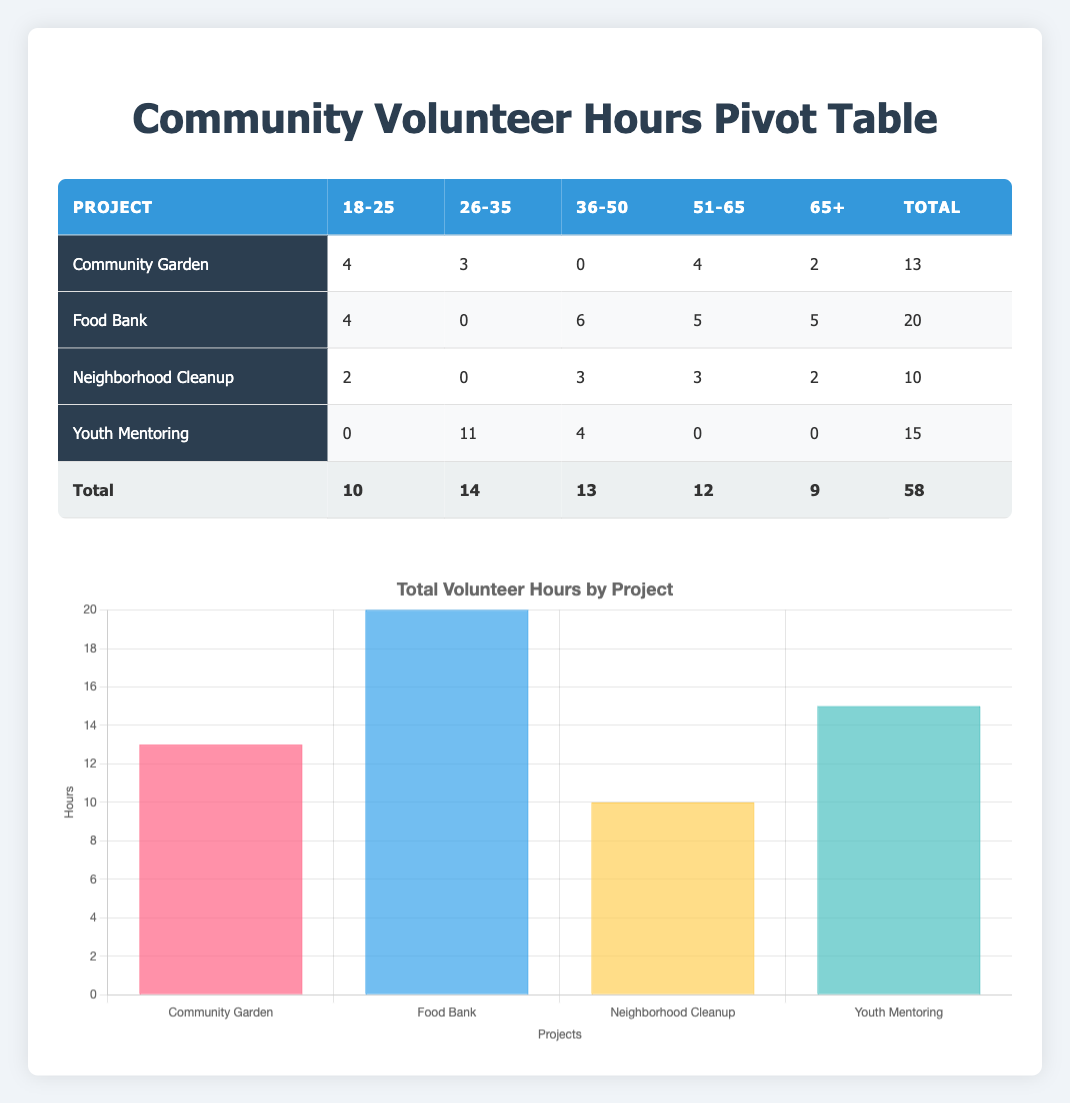What is the total number of volunteer hours contributed to the Community Garden project? In the table, under the Community Garden project, the total hours contributed across all age groups are as follows: 4 (18-25) + 3 (26-35) + 0 (36-50) + 4 (51-65) + 2 (65+) = 13.
Answer: 13 How many hours did the 36-50 age group contribute to the Food Bank project? In the Food Bank section, under the 36-50 age group, the hours contributed are listed as 6.
Answer: 6 Is it true that the Youth Mentoring project received more volunteer hours from the 26-35 age group than the Neighborhood Cleanup project? For the Youth Mentoring project, the 26-35 age group's contribution was 11 hours, while for the Neighborhood Cleanup project, the contribution was 0 hours. Since 11 is greater than 0, the statement is true.
Answer: Yes What is the total number of volunteer hours contributed by the 65+ age group across all projects? To find this total, we sum the hours from the 65+ age group for all projects: Community Garden (2) + Food Bank (5) + Neighborhood Cleanup (2) + Youth Mentoring (0) = 9.
Answer: 9 Which project has the highest total volunteer hours, and how many hours did it receive? Looking at the total column for all projects, the project with the highest total is the Food Bank, which received 20 hours.
Answer: Food Bank, 20 What is the average number of hours contributed by the 18-25 age group across all projects? The total hours for the 18-25 age group are: Community Garden (4) + Food Bank (4) + Neighborhood Cleanup (2) + Youth Mentoring (0) = 10. There are 4 entries for this age group, so we calculate the average as 10/4 = 2.5.
Answer: 2.5 How many more total hours were contributed to the Youth Mentoring project compared to the Neighborhood Cleanup project? Total hours for Youth Mentoring are 15, and for Neighborhood Cleanup, they are 10. The difference is 15 - 10 = 5 hours.
Answer: 5 Did any demographic group contribute hours to the Food Bank project? Yes, there are contributions from all age groups listed for the Food Bank: 18-25 (4), 36-50 (6), 65+ (5). Therefore, there was participation from multiple demographic groups.
Answer: Yes What proportion of the total volunteer hours came from the 26-35 age group? The total hours for the 26-35 age group across all projects is 14, while the total hours overall is 58. To find the proportion, calculate 14/58, which is approximately 0.241. So the proportion is around 24.1%.
Answer: 24.1% 